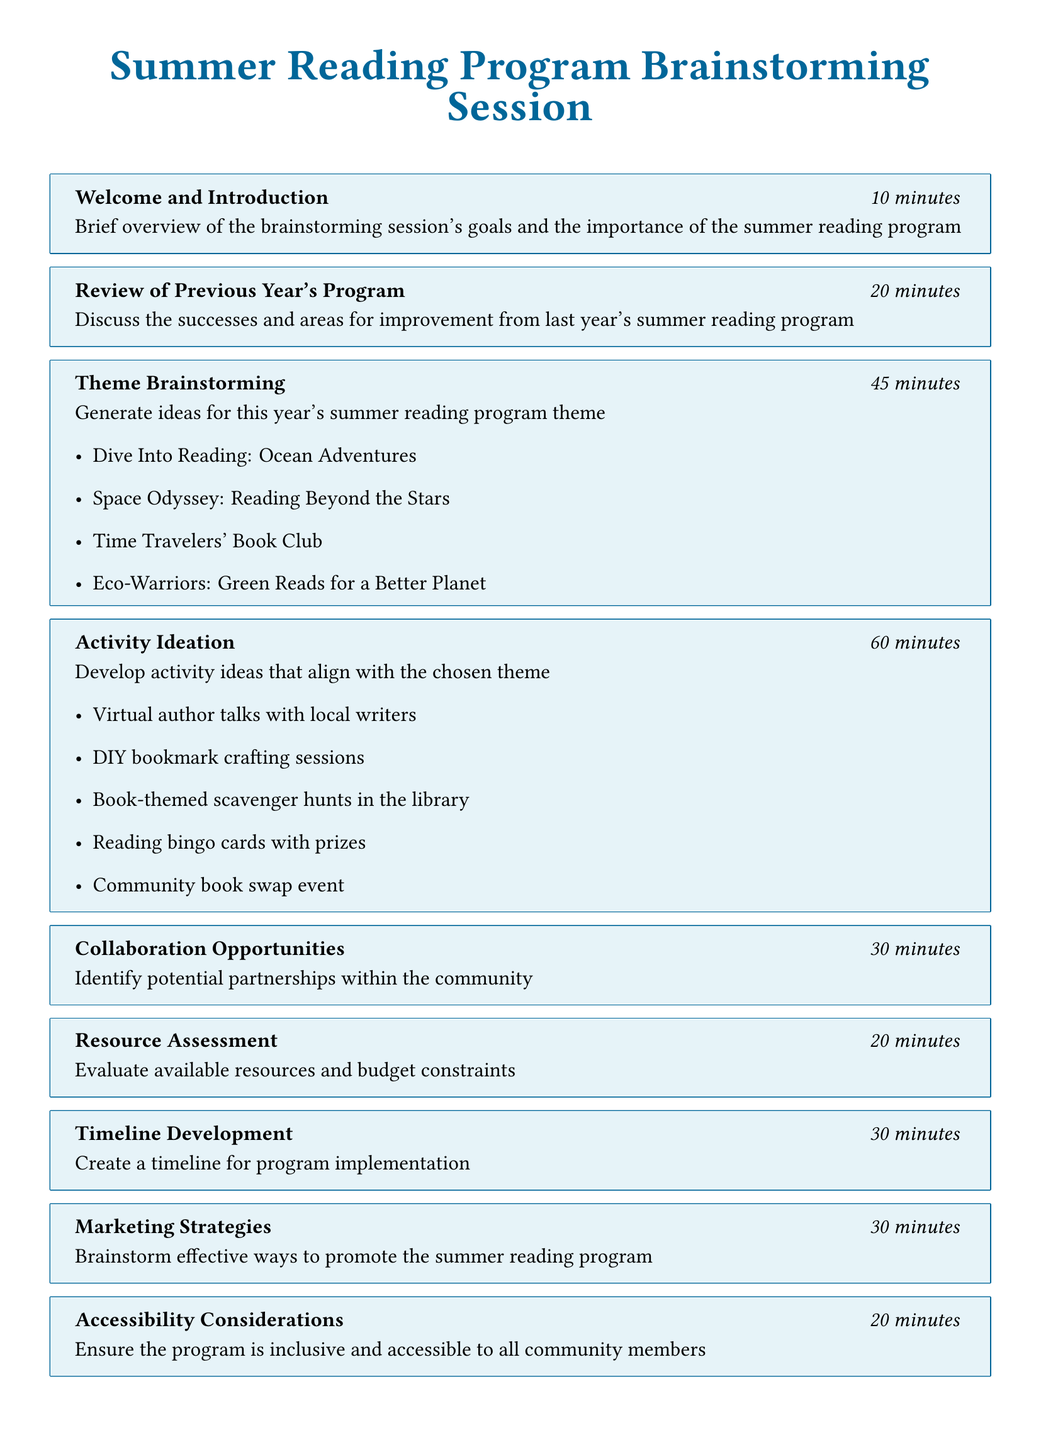What is the duration of the Welcome and Introduction? The duration is indicated in the agenda item section for "Welcome and Introduction," which shows the specific time allocated for that part.
Answer: 10 minutes What is a potential theme for the summer reading program? The document lists various potential themes in the "Theme Brainstorming" section, demonstrating ideas for the program.
Answer: Dive Into Reading: Ocean Adventures How long is allocated for Activity Ideation? The duration specified for "Activity Ideation" in the agenda is sought for clarity on the length of this section.
Answer: 60 minutes What date is the program kick-off scheduled? The key dates mentioned in "Timeline Development" provide essential information for scheduling the program start.
Answer: June 15th How many minutes are dedicated to Collaboration Opportunities? This question refers to the duration under the "Collaboration Opportunities" item on the agenda, which outlines the time for this discussion.
Answer: 30 minutes What type of event is proposed in the potential activities section? The "Activity Ideation" portion lists various activities, one of which is a specific event included for participation.
Answer: Community book swap event What is one focus area under Accessibility Considerations? This refers to the stated areas of focus in the "Accessibility Considerations" section, providing insight into inclusivity efforts for the program.
Answer: Digital accessibility What is the total duration for the wrap-up and next steps? The total duration can be easily found under the "Wrap-up and Next Steps" item in the agenda, reflecting the allotted time for conclusion.
Answer: 15 minutes 